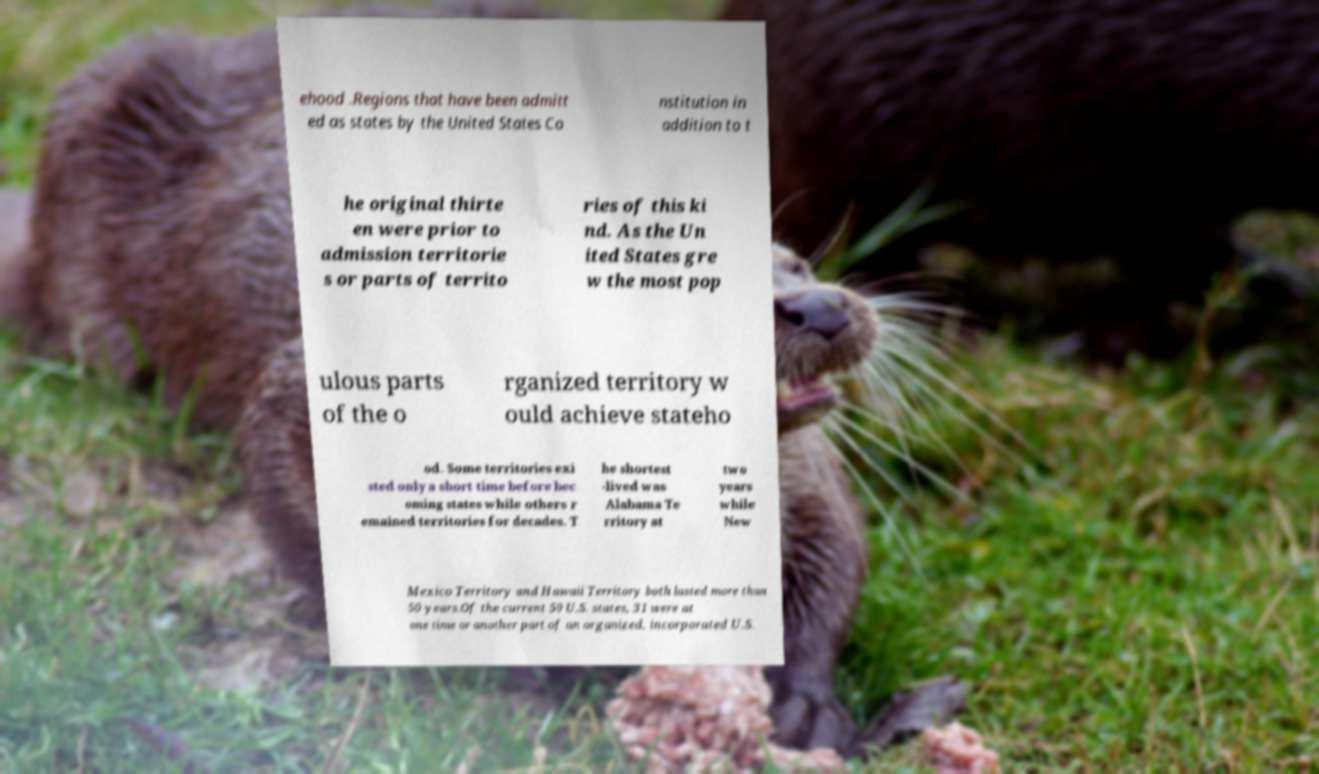I need the written content from this picture converted into text. Can you do that? ehood .Regions that have been admitt ed as states by the United States Co nstitution in addition to t he original thirte en were prior to admission territorie s or parts of territo ries of this ki nd. As the Un ited States gre w the most pop ulous parts of the o rganized territory w ould achieve stateho od. Some territories exi sted only a short time before bec oming states while others r emained territories for decades. T he shortest -lived was Alabama Te rritory at two years while New Mexico Territory and Hawaii Territory both lasted more than 50 years.Of the current 50 U.S. states, 31 were at one time or another part of an organized, incorporated U.S. 